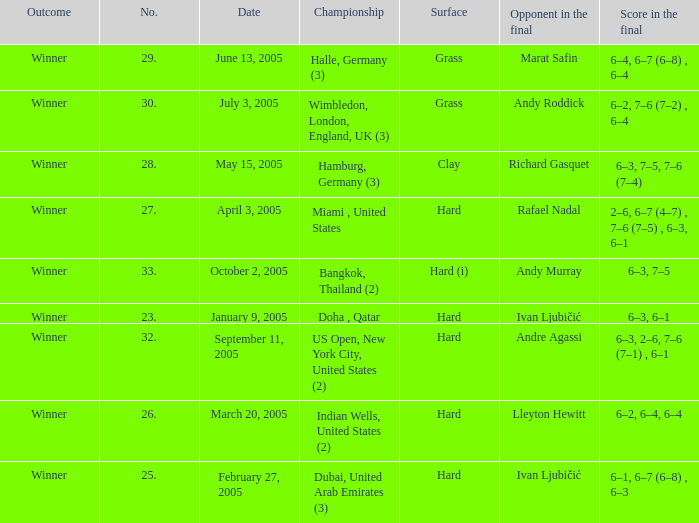How many championships are there on the date January 9, 2005? 1.0. 